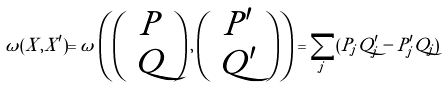<formula> <loc_0><loc_0><loc_500><loc_500>\omega ( X , X ^ { \prime } ) = \omega \left ( \left ( \begin{array} { c } P \\ Q \end{array} \right ) , \left ( \begin{array} { c } P ^ { \prime } \\ Q ^ { \prime } \end{array} \right ) \right ) = \sum _ { j } ( P _ { j } Q _ { j } ^ { \prime } - P _ { j } ^ { \prime } Q _ { j } )</formula> 